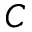Convert formula to latex. <formula><loc_0><loc_0><loc_500><loc_500>C</formula> 